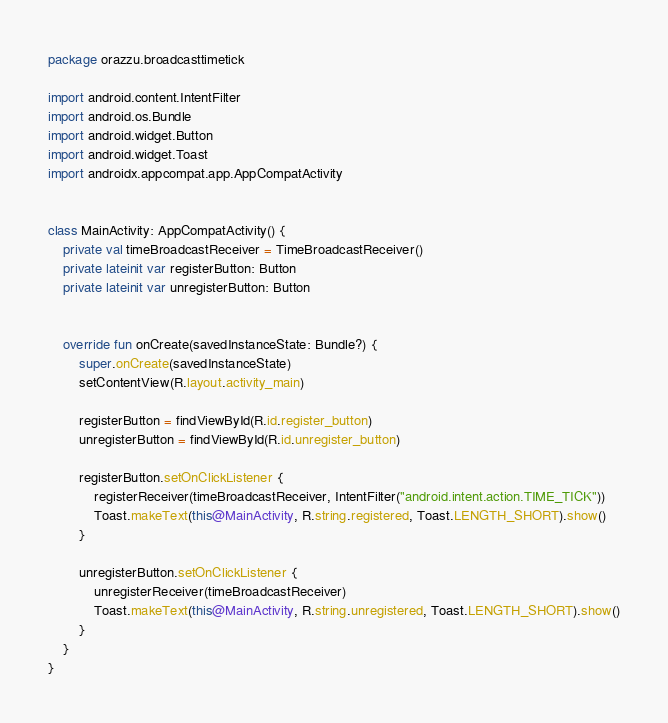Convert code to text. <code><loc_0><loc_0><loc_500><loc_500><_Kotlin_>package orazzu.broadcasttimetick

import android.content.IntentFilter
import android.os.Bundle
import android.widget.Button
import android.widget.Toast
import androidx.appcompat.app.AppCompatActivity


class MainActivity: AppCompatActivity() {
    private val timeBroadcastReceiver = TimeBroadcastReceiver()
    private lateinit var registerButton: Button
    private lateinit var unregisterButton: Button


    override fun onCreate(savedInstanceState: Bundle?) {
        super.onCreate(savedInstanceState)
        setContentView(R.layout.activity_main)

        registerButton = findViewById(R.id.register_button)
        unregisterButton = findViewById(R.id.unregister_button)

        registerButton.setOnClickListener {
            registerReceiver(timeBroadcastReceiver, IntentFilter("android.intent.action.TIME_TICK"))
            Toast.makeText(this@MainActivity, R.string.registered, Toast.LENGTH_SHORT).show()
        }

        unregisterButton.setOnClickListener {
            unregisterReceiver(timeBroadcastReceiver)
            Toast.makeText(this@MainActivity, R.string.unregistered, Toast.LENGTH_SHORT).show()
        }
    }
}</code> 